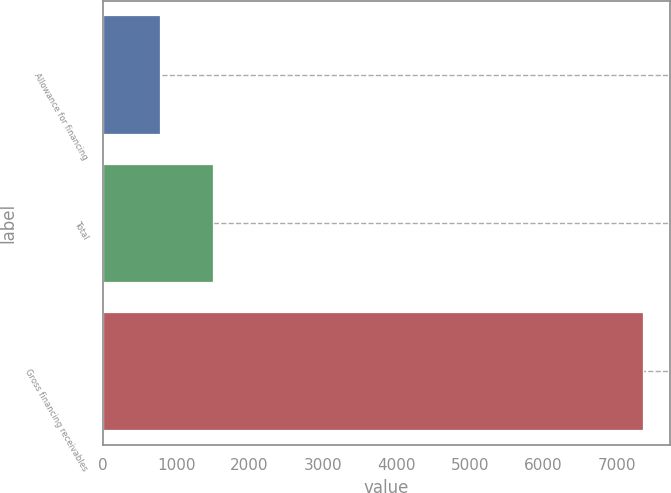<chart> <loc_0><loc_0><loc_500><loc_500><bar_chart><fcel>Allowance for financing<fcel>Total<fcel>Gross financing receivables<nl><fcel>776<fcel>1507<fcel>7355<nl></chart> 